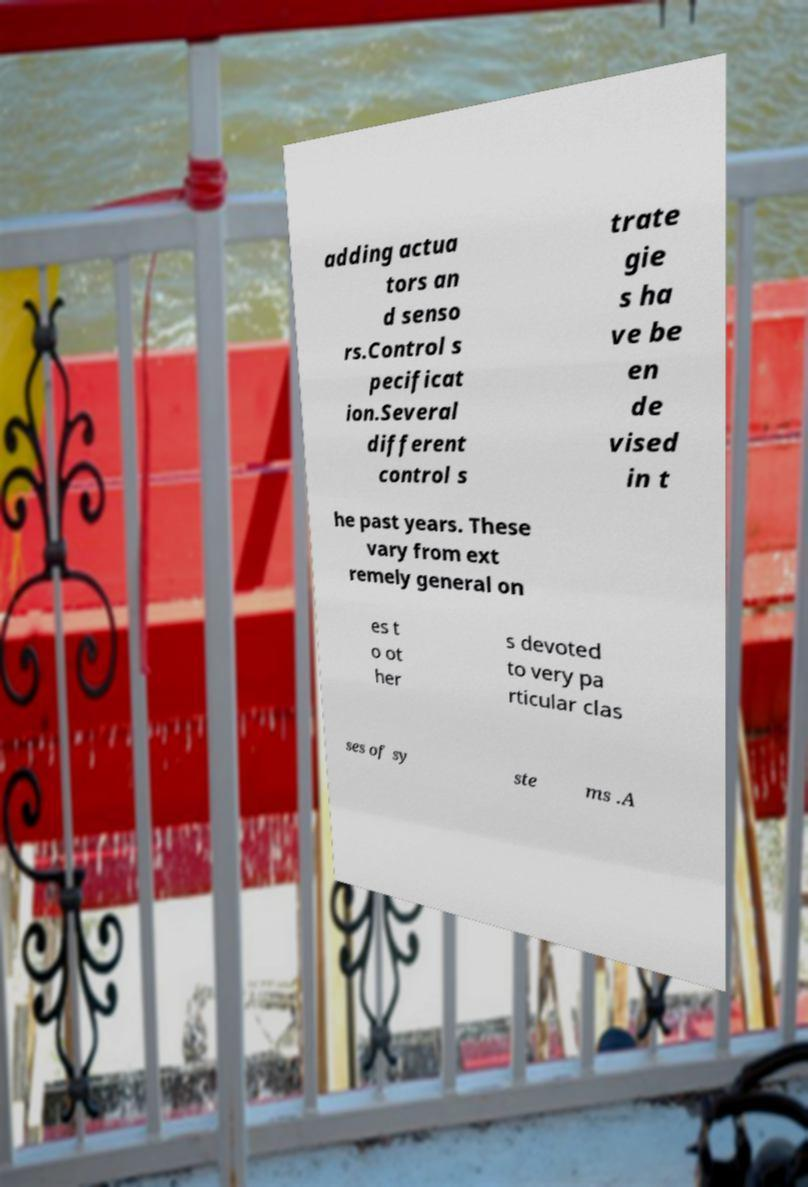Could you extract and type out the text from this image? adding actua tors an d senso rs.Control s pecificat ion.Several different control s trate gie s ha ve be en de vised in t he past years. These vary from ext remely general on es t o ot her s devoted to very pa rticular clas ses of sy ste ms .A 